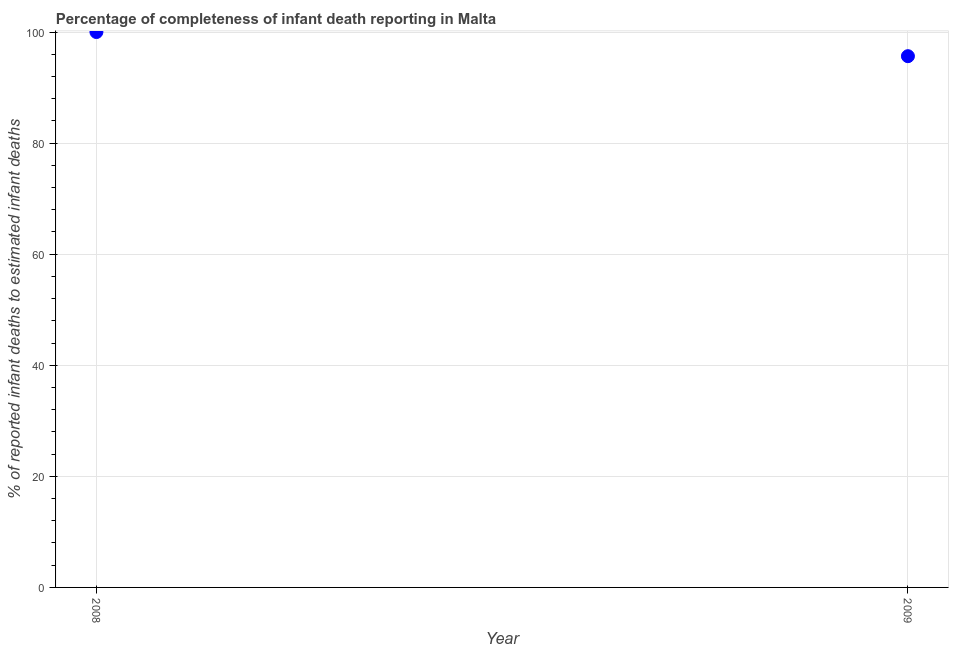What is the completeness of infant death reporting in 2009?
Your answer should be compact. 95.65. Across all years, what is the minimum completeness of infant death reporting?
Keep it short and to the point. 95.65. What is the sum of the completeness of infant death reporting?
Ensure brevity in your answer.  195.65. What is the difference between the completeness of infant death reporting in 2008 and 2009?
Your answer should be compact. 4.35. What is the average completeness of infant death reporting per year?
Keep it short and to the point. 97.83. What is the median completeness of infant death reporting?
Provide a succinct answer. 97.83. In how many years, is the completeness of infant death reporting greater than 40 %?
Make the answer very short. 2. What is the ratio of the completeness of infant death reporting in 2008 to that in 2009?
Provide a succinct answer. 1.05. In how many years, is the completeness of infant death reporting greater than the average completeness of infant death reporting taken over all years?
Make the answer very short. 1. Does the completeness of infant death reporting monotonically increase over the years?
Keep it short and to the point. No. How many dotlines are there?
Provide a short and direct response. 1. What is the difference between two consecutive major ticks on the Y-axis?
Offer a very short reply. 20. Does the graph contain any zero values?
Your answer should be very brief. No. Does the graph contain grids?
Keep it short and to the point. Yes. What is the title of the graph?
Your response must be concise. Percentage of completeness of infant death reporting in Malta. What is the label or title of the Y-axis?
Your answer should be compact. % of reported infant deaths to estimated infant deaths. What is the % of reported infant deaths to estimated infant deaths in 2009?
Your answer should be compact. 95.65. What is the difference between the % of reported infant deaths to estimated infant deaths in 2008 and 2009?
Your answer should be compact. 4.35. What is the ratio of the % of reported infant deaths to estimated infant deaths in 2008 to that in 2009?
Make the answer very short. 1.04. 